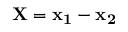Convert formula to latex. <formula><loc_0><loc_0><loc_500><loc_500>X = x _ { 1 } - x _ { 2 }</formula> 